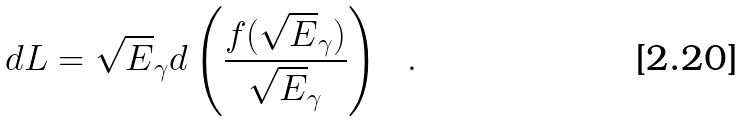Convert formula to latex. <formula><loc_0><loc_0><loc_500><loc_500>d L = \sqrt { E } _ { \gamma } d \left ( \frac { f ( \sqrt { E } _ { \gamma } ) } { \sqrt { E } _ { \gamma } } \right ) \ \ .</formula> 